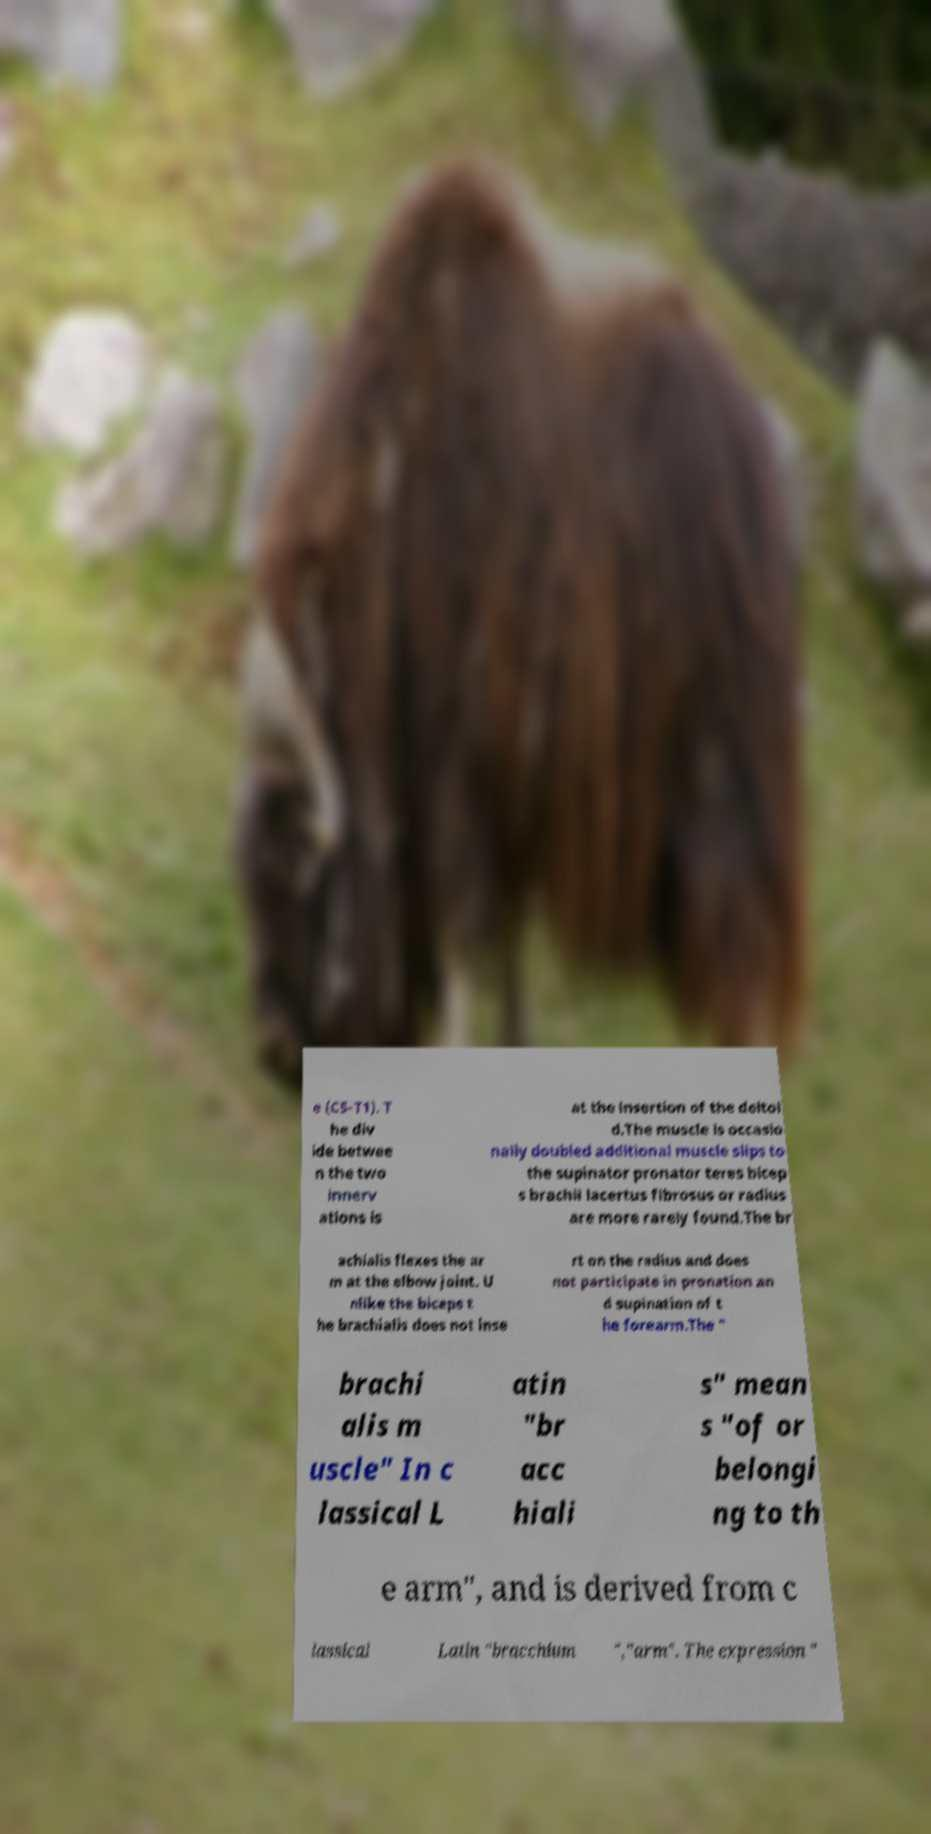Can you read and provide the text displayed in the image?This photo seems to have some interesting text. Can you extract and type it out for me? e (C5-T1). T he div ide betwee n the two innerv ations is at the insertion of the deltoi d.The muscle is occasio nally doubled additional muscle slips to the supinator pronator teres bicep s brachii lacertus fibrosus or radius are more rarely found.The br achialis flexes the ar m at the elbow joint. U nlike the biceps t he brachialis does not inse rt on the radius and does not participate in pronation an d supination of t he forearm.The " brachi alis m uscle" In c lassical L atin "br acc hiali s" mean s "of or belongi ng to th e arm", and is derived from c lassical Latin "bracchium ","arm". The expression " 